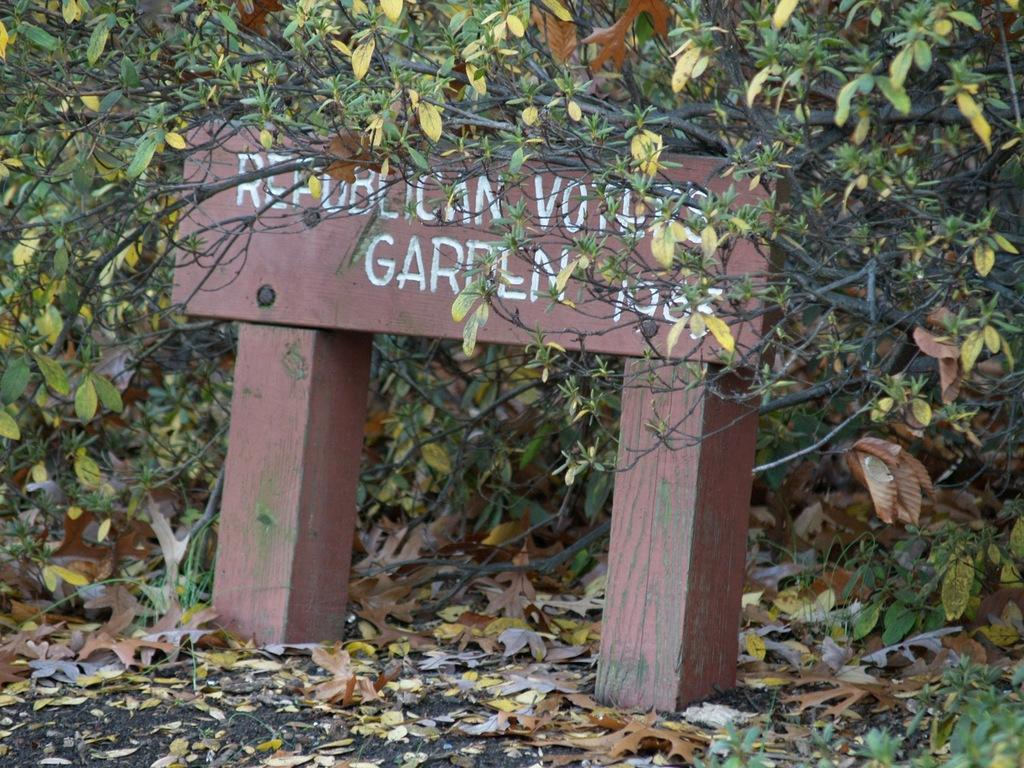What type of vegetation can be seen in the image? There are trees in the image. What is the board with text used for in the image? The board with text is used for displaying information or a message in the image. What is present on the ground in the image? Leaves are present on the ground in the image. How many jellyfish can be seen swimming in the image? There are no jellyfish present in the image. What type of organization is responsible for maintaining the area in the image? There is no information about an organization responsible for maintaining the area in the image. 